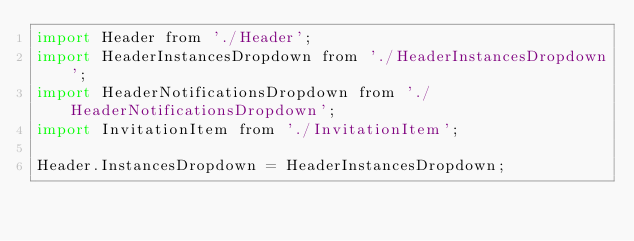<code> <loc_0><loc_0><loc_500><loc_500><_JavaScript_>import Header from './Header';
import HeaderInstancesDropdown from './HeaderInstancesDropdown';
import HeaderNotificationsDropdown from './HeaderNotificationsDropdown';
import InvitationItem from './InvitationItem';

Header.InstancesDropdown = HeaderInstancesDropdown;</code> 